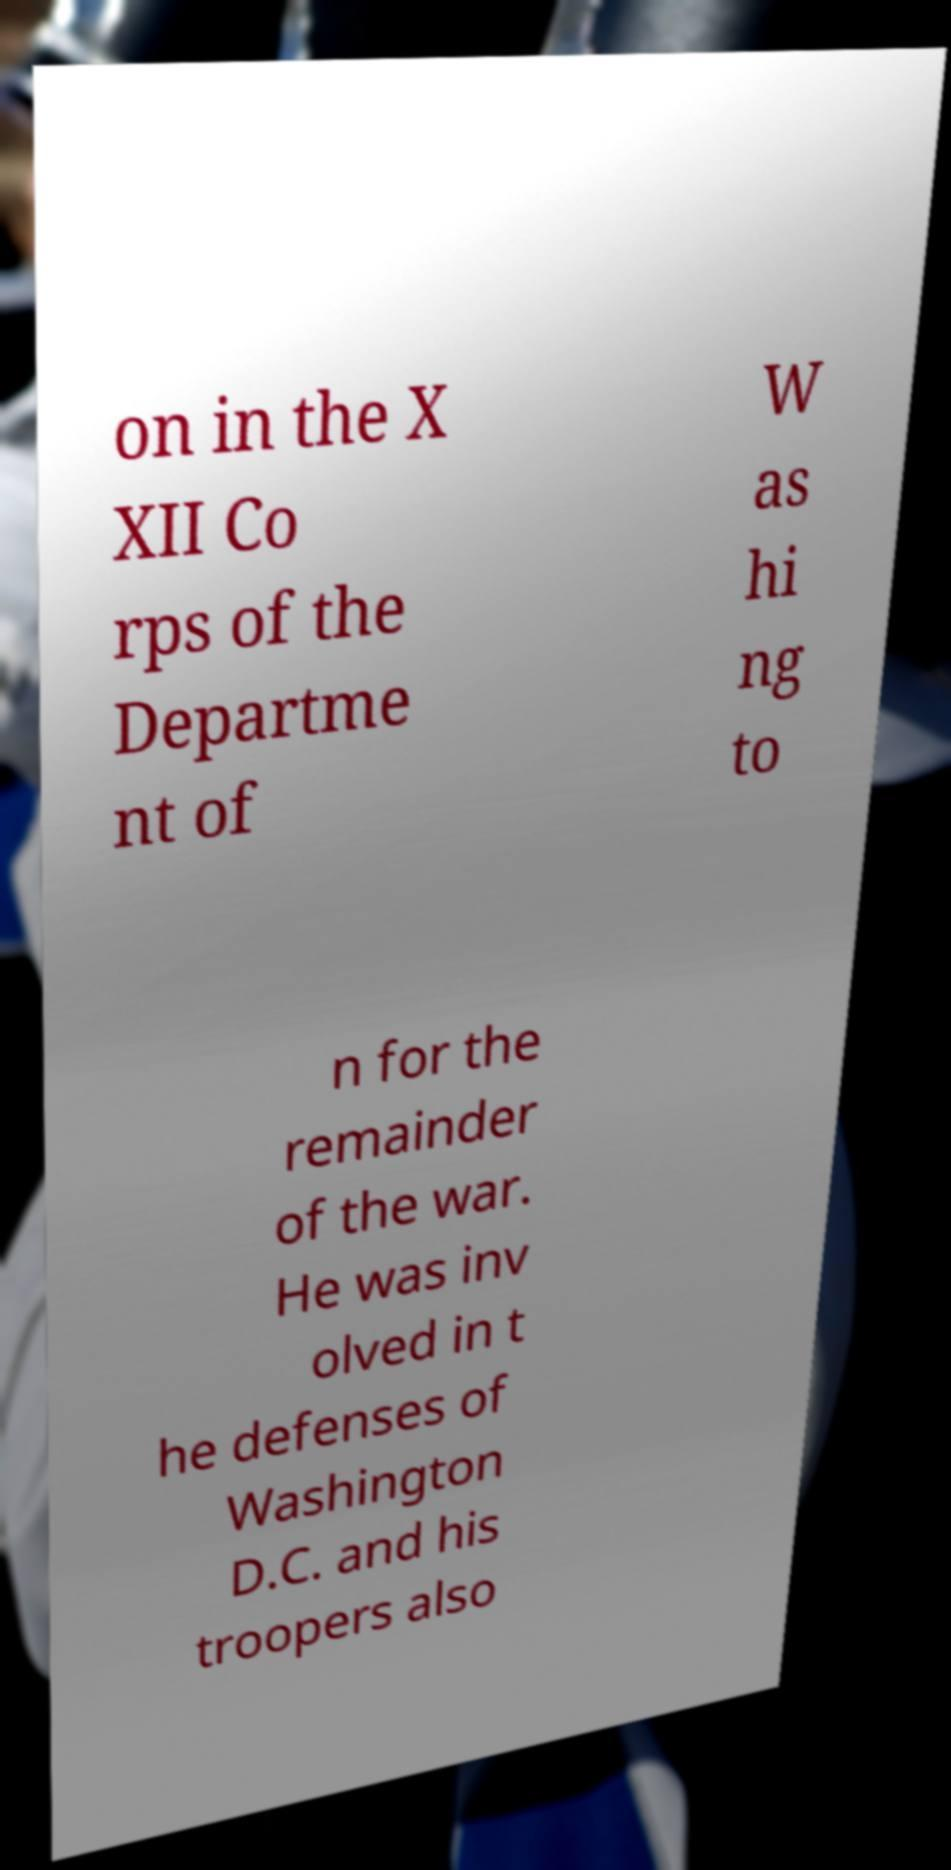What messages or text are displayed in this image? I need them in a readable, typed format. on in the X XII Co rps of the Departme nt of W as hi ng to n for the remainder of the war. He was inv olved in t he defenses of Washington D.C. and his troopers also 